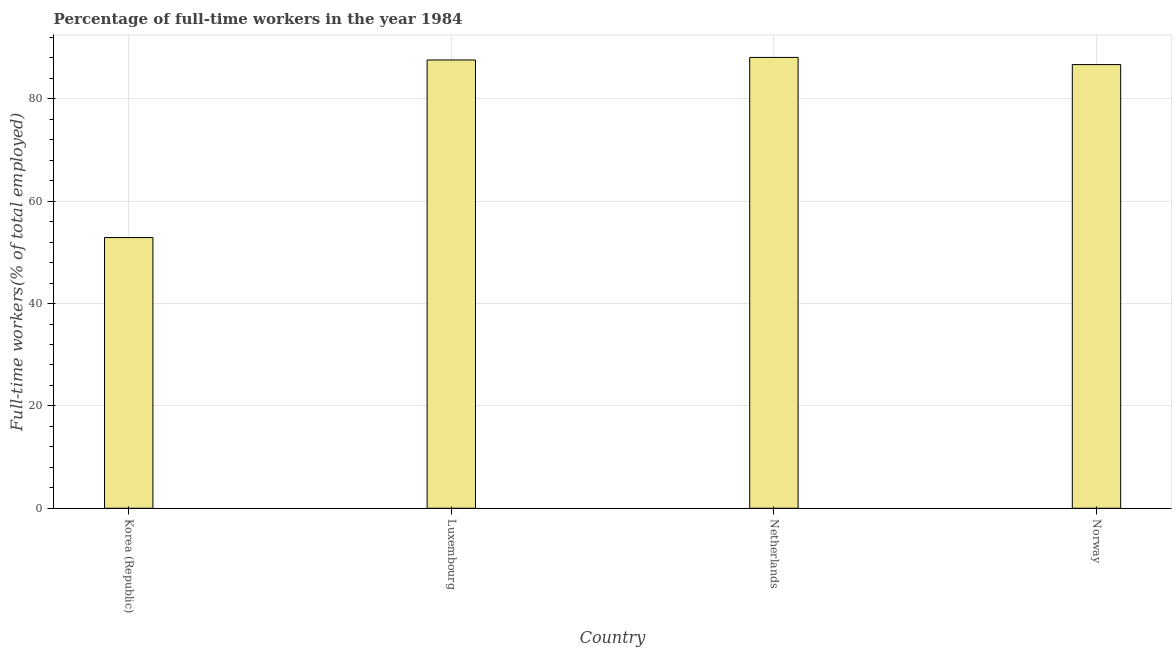Does the graph contain any zero values?
Keep it short and to the point. No. What is the title of the graph?
Ensure brevity in your answer.  Percentage of full-time workers in the year 1984. What is the label or title of the Y-axis?
Provide a short and direct response. Full-time workers(% of total employed). What is the percentage of full-time workers in Norway?
Provide a short and direct response. 86.7. Across all countries, what is the maximum percentage of full-time workers?
Make the answer very short. 88.1. Across all countries, what is the minimum percentage of full-time workers?
Provide a short and direct response. 52.9. In which country was the percentage of full-time workers maximum?
Give a very brief answer. Netherlands. In which country was the percentage of full-time workers minimum?
Your answer should be compact. Korea (Republic). What is the sum of the percentage of full-time workers?
Provide a succinct answer. 315.3. What is the difference between the percentage of full-time workers in Luxembourg and Netherlands?
Your answer should be very brief. -0.5. What is the average percentage of full-time workers per country?
Provide a short and direct response. 78.83. What is the median percentage of full-time workers?
Give a very brief answer. 87.15. Is the percentage of full-time workers in Netherlands less than that in Norway?
Keep it short and to the point. No. What is the difference between the highest and the second highest percentage of full-time workers?
Your answer should be compact. 0.5. What is the difference between the highest and the lowest percentage of full-time workers?
Provide a succinct answer. 35.2. In how many countries, is the percentage of full-time workers greater than the average percentage of full-time workers taken over all countries?
Ensure brevity in your answer.  3. How many bars are there?
Your response must be concise. 4. How many countries are there in the graph?
Keep it short and to the point. 4. What is the difference between two consecutive major ticks on the Y-axis?
Ensure brevity in your answer.  20. What is the Full-time workers(% of total employed) of Korea (Republic)?
Offer a terse response. 52.9. What is the Full-time workers(% of total employed) of Luxembourg?
Provide a short and direct response. 87.6. What is the Full-time workers(% of total employed) in Netherlands?
Make the answer very short. 88.1. What is the Full-time workers(% of total employed) in Norway?
Offer a very short reply. 86.7. What is the difference between the Full-time workers(% of total employed) in Korea (Republic) and Luxembourg?
Your answer should be very brief. -34.7. What is the difference between the Full-time workers(% of total employed) in Korea (Republic) and Netherlands?
Your response must be concise. -35.2. What is the difference between the Full-time workers(% of total employed) in Korea (Republic) and Norway?
Give a very brief answer. -33.8. What is the difference between the Full-time workers(% of total employed) in Luxembourg and Netherlands?
Your answer should be very brief. -0.5. What is the difference between the Full-time workers(% of total employed) in Luxembourg and Norway?
Provide a short and direct response. 0.9. What is the difference between the Full-time workers(% of total employed) in Netherlands and Norway?
Your response must be concise. 1.4. What is the ratio of the Full-time workers(% of total employed) in Korea (Republic) to that in Luxembourg?
Keep it short and to the point. 0.6. What is the ratio of the Full-time workers(% of total employed) in Korea (Republic) to that in Norway?
Your answer should be compact. 0.61. What is the ratio of the Full-time workers(% of total employed) in Luxembourg to that in Netherlands?
Your response must be concise. 0.99. 